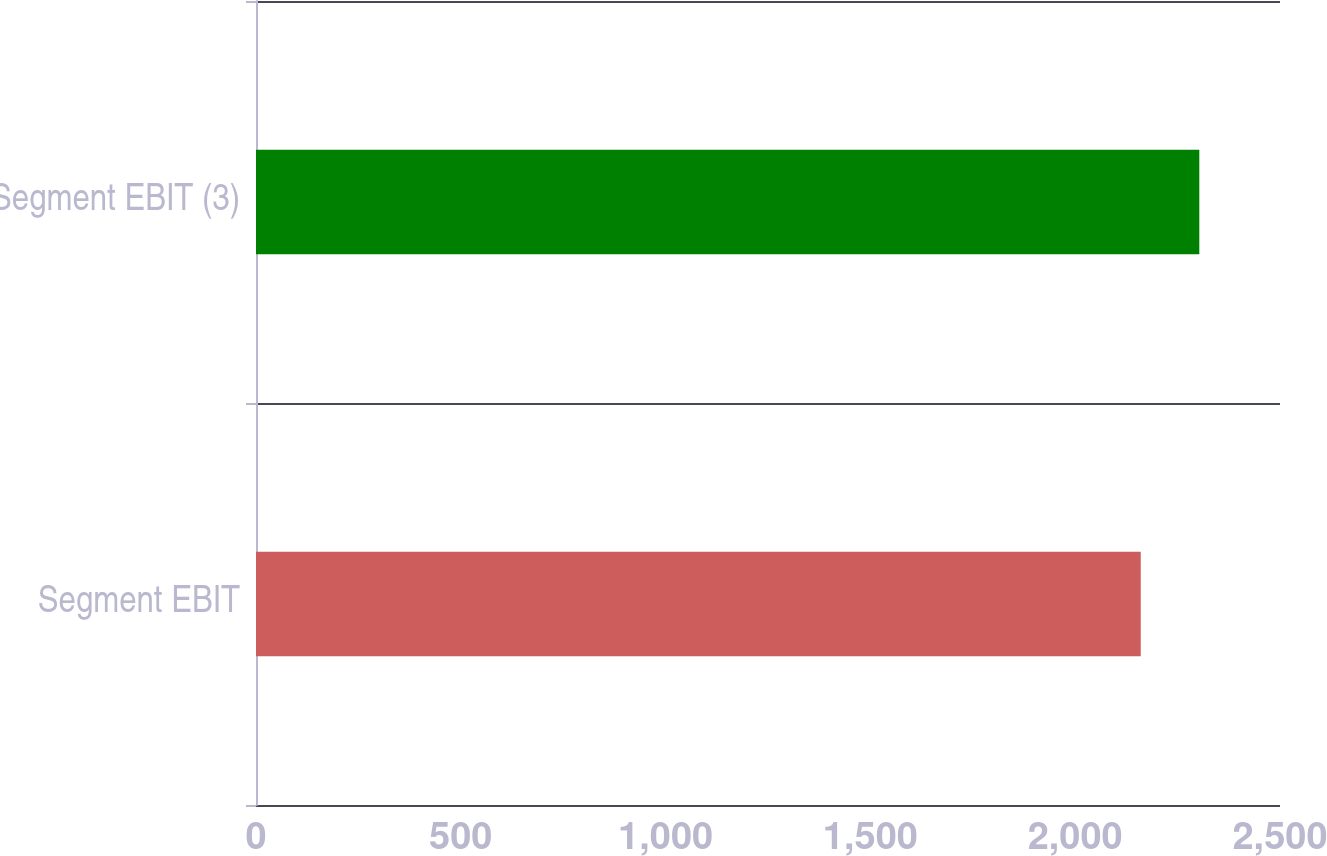Convert chart. <chart><loc_0><loc_0><loc_500><loc_500><bar_chart><fcel>Segment EBIT<fcel>Segment EBIT (3)<nl><fcel>2160<fcel>2303<nl></chart> 